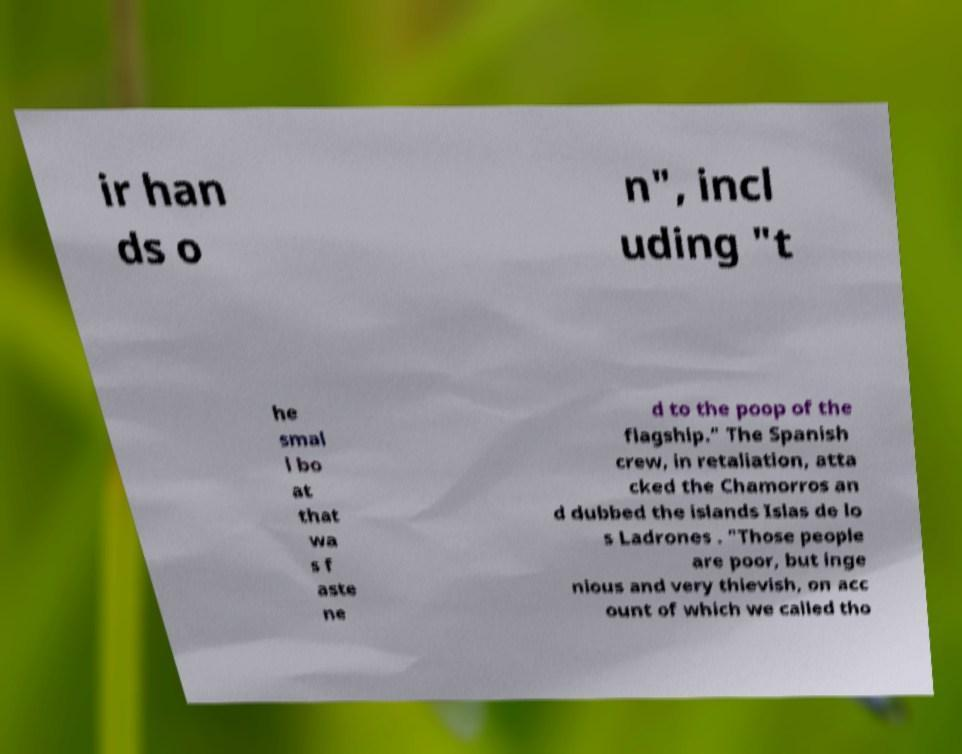For documentation purposes, I need the text within this image transcribed. Could you provide that? ir han ds o n", incl uding "t he smal l bo at that wa s f aste ne d to the poop of the flagship." The Spanish crew, in retaliation, atta cked the Chamorros an d dubbed the islands Islas de lo s Ladrones . "Those people are poor, but inge nious and very thievish, on acc ount of which we called tho 